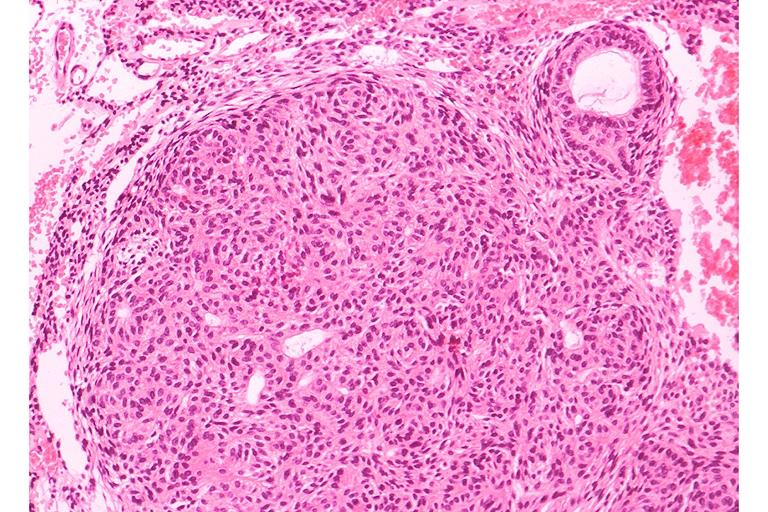s uterus present?
Answer the question using a single word or phrase. No 